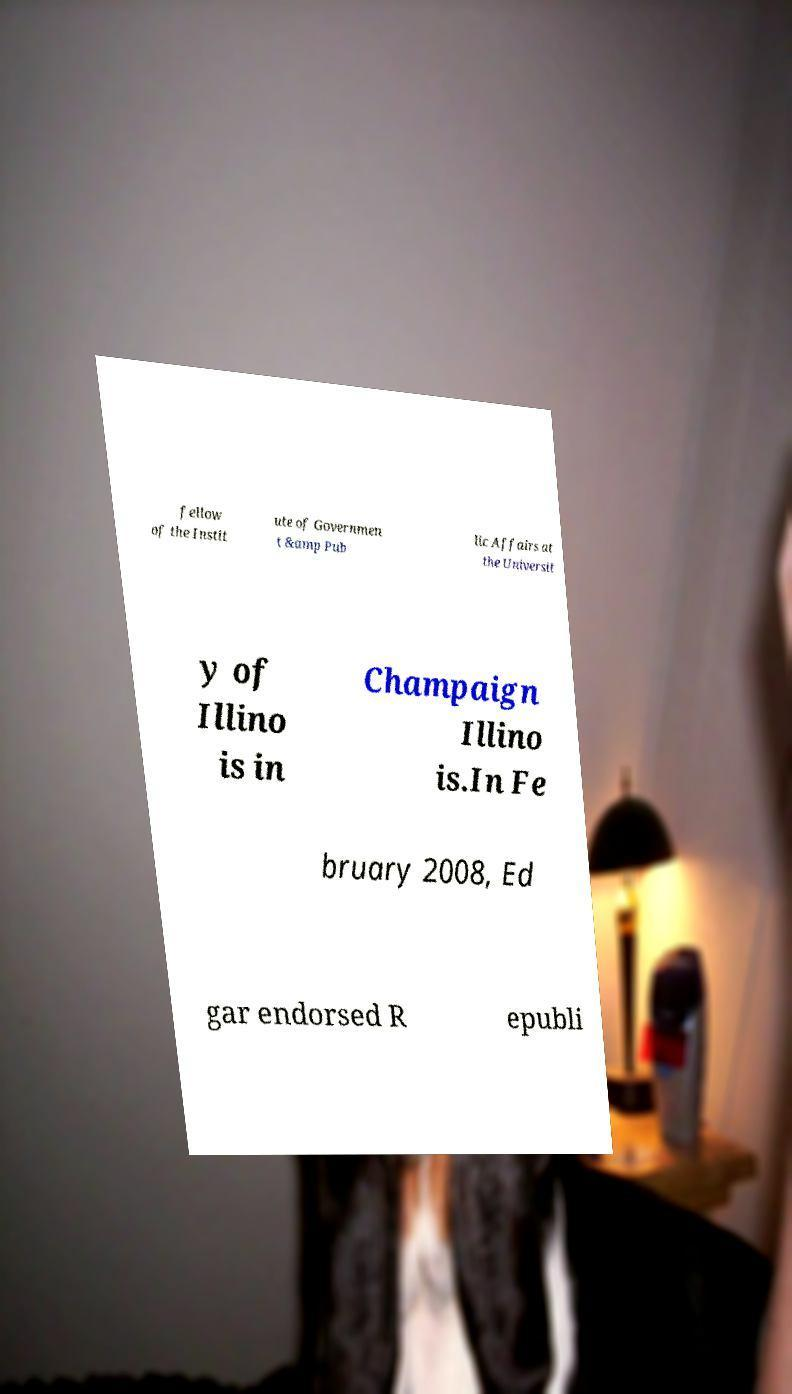There's text embedded in this image that I need extracted. Can you transcribe it verbatim? fellow of the Instit ute of Governmen t &amp Pub lic Affairs at the Universit y of Illino is in Champaign Illino is.In Fe bruary 2008, Ed gar endorsed R epubli 